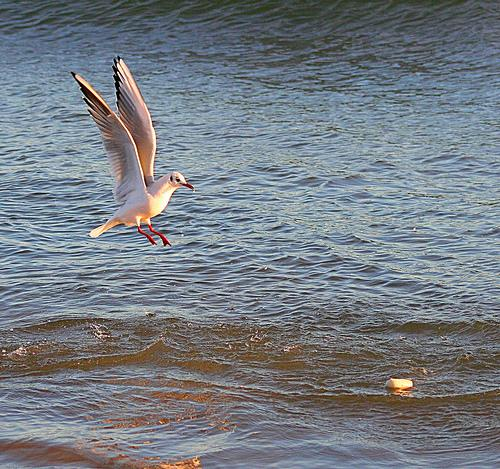Question: how many pieces of food can be seen sitting on top of the water?
Choices:
A. One.
B. Two.
C. Zero.
D. Three.
Answer with the letter. Answer: A Question: where is the food located?
Choices:
A. On a table.
B. On a counter.
C. On a picnic blanket.
D. On top of the water.
Answer with the letter. Answer: D Question: what color are the birds talons?
Choices:
A. Orange.
B. Red.
C. Yellow.
D. Black.
Answer with the letter. Answer: A 